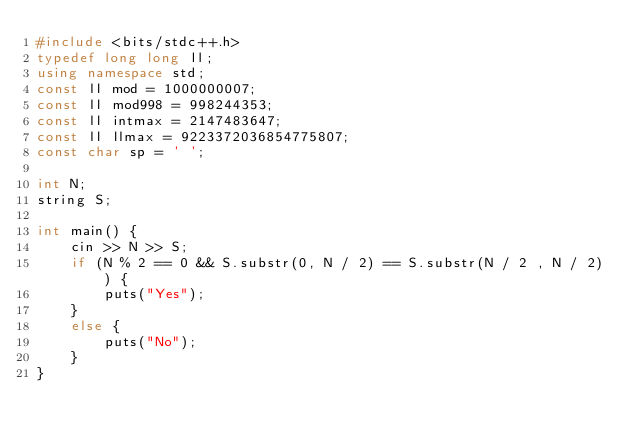Convert code to text. <code><loc_0><loc_0><loc_500><loc_500><_C++_>#include <bits/stdc++.h>
typedef long long ll;
using namespace std;
const ll mod = 1000000007;
const ll mod998 = 998244353;
const ll intmax = 2147483647;
const ll llmax = 9223372036854775807;
const char sp = ' ';

int N;
string S;

int main() {
	cin >> N >> S;
	if (N % 2 == 0 && S.substr(0, N / 2) == S.substr(N / 2 , N / 2)) {
		puts("Yes");
	}
	else {
		puts("No");
	}
}</code> 